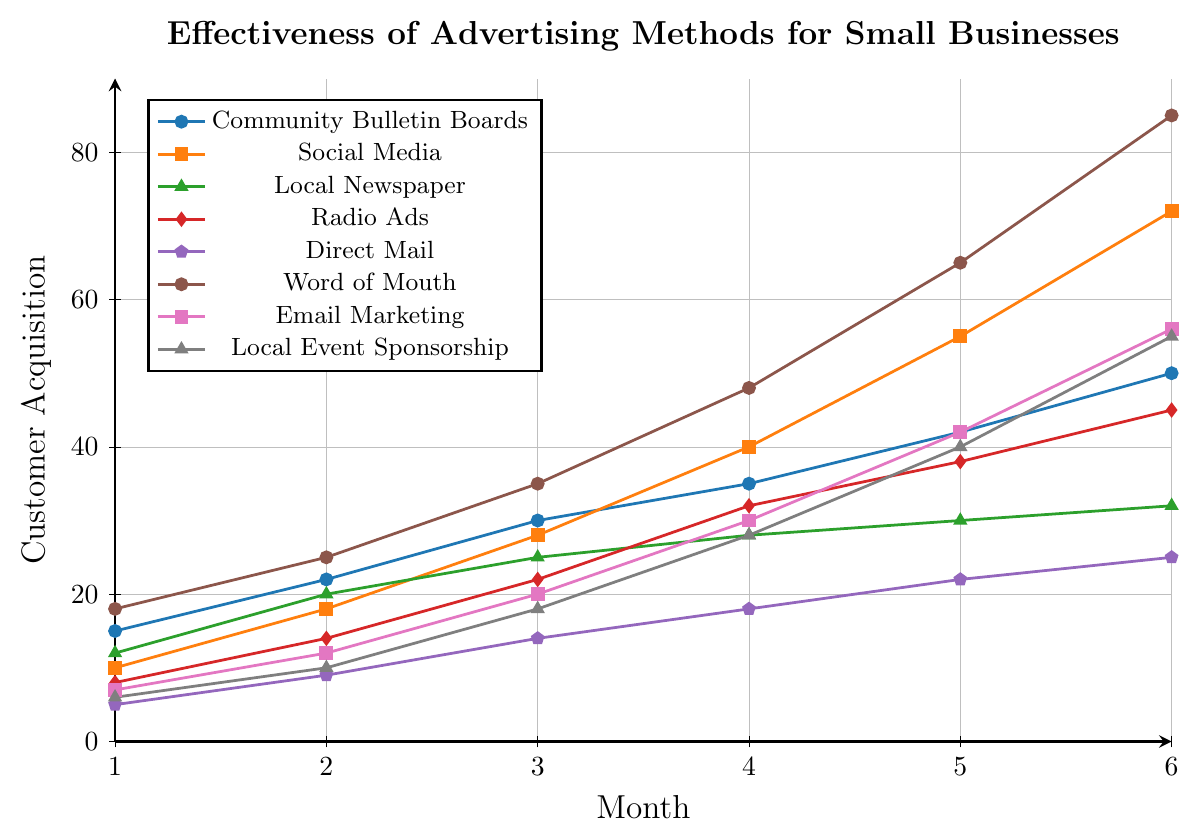Which advertising method has the highest customer acquisition by Month 6? Locate Month 6 on the x-axis and compare the y-values of all methods. The line for "Word of Mouth" reaches the highest at 85 customers.
Answer: Word of Mouth Which advertising method shows the most significant overall increase from Month 1 to Month 6? Calculate the difference between Month 1 and Month 6 values for each method. "Word of Mouth" increases from 18 to 85, which is a 67-customer increase, the highest among all methods.
Answer: Word of Mouth Is the customer acquisition trend for "Community Bulletin Boards" generally increasing, decreasing, or steady over the 6 months? Observe the y-values of "Community Bulletin Boards" from Month 1 to Month 6. Each month shows an increase from 15 to 50.
Answer: Increasing Between "Radio Ads" and "Local Newspaper," which method had more customer acquisitions on Month 4? Compare the y-values for "Radio Ads" and "Local Newspaper" at Month 4. "Radio Ads" has 32, while "Local Newspaper" has 28.
Answer: Radio Ads What is the difference in customer acquisition between "Social Media" and "Email Marketing" by Month 3? Find the y-values for "Social Media" and "Email Marketing" at Month 3. "Social Media" has 28, and "Email Marketing" has 20. The difference is 28-20.
Answer: 8 By how much did the customer acquisition for "Direct Mail" increase from Month 2 to Month 5? Calculate the difference between Month 5 and Month 2 for "Direct Mail". Month 5 has 22 customers and Month 2 has 9 customers. The increase is 22-9.
Answer: 13 Which advertising method has the lowest customer acquisition by Month 6? Locate Month 6 on the x-axis and compare the y-values of all methods. The line for "Direct Mail" is the lowest at 25 customers.
Answer: Direct Mail Compare the customer acquisition trends of "Local Event Sponsorship" and "Email Marketing." Which method shows a faster rate of increase? Observe the slopes of the lines for both methods. "Local Event Sponsorship" goes from 6 to 55, and "Email Marketing" goes from 7 to 56. Both start similarly, but "Email Marketing" reaches a higher value faster, indicating a steeper slope earlier.
Answer: Email Marketing Across all methods, which month shows the highest increase in customer acquisitions for "Word of Mouth"? Examine the increases between consecutive months for "Word of Mouth." It shows the largest increase between Month 5 (65) and Month 6 (85), an increase of 20 customers.
Answer: Month 6 What is the average customer acquisition for "Community Bulletin Boards" over the 6 months? Sum the values for each month (15+22+30+35+42+50=194) and divide by 6. The average is 194/6.
Answer: 32.33 